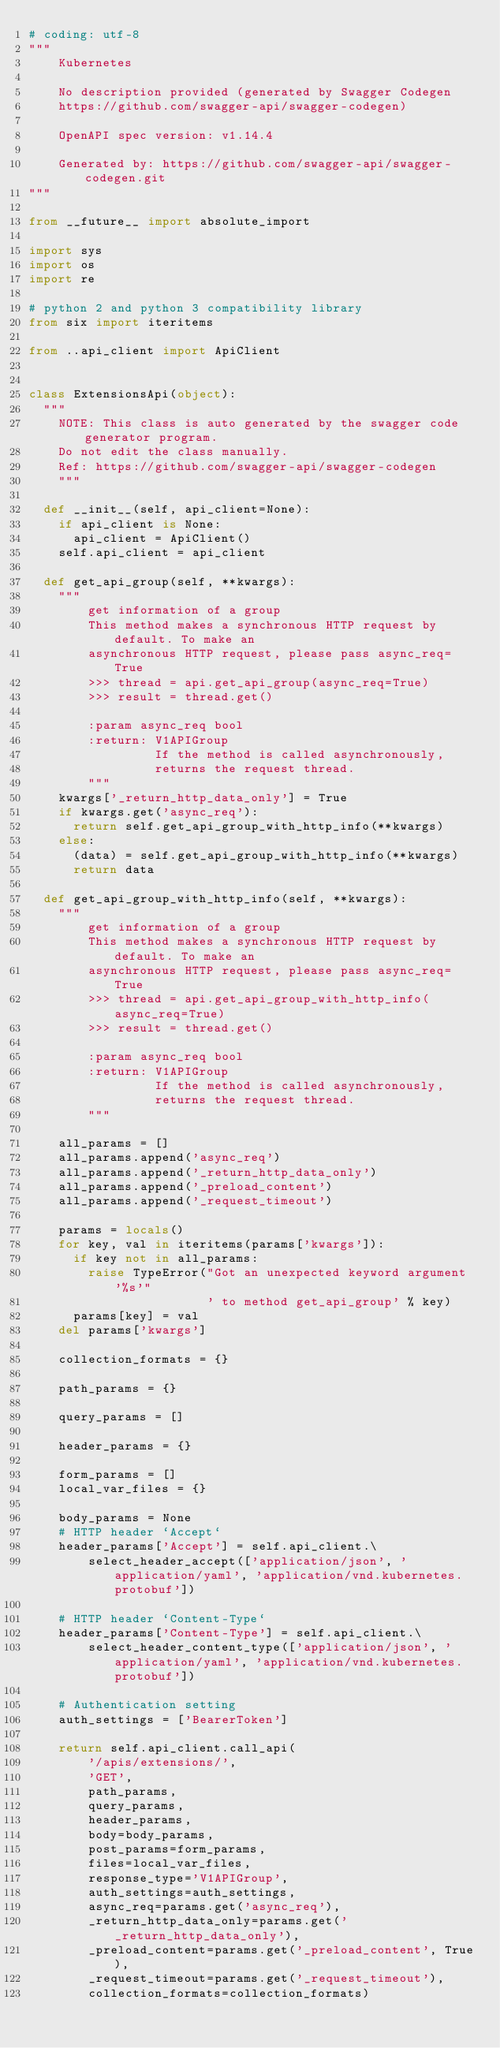Convert code to text. <code><loc_0><loc_0><loc_500><loc_500><_Python_># coding: utf-8
"""
    Kubernetes

    No description provided (generated by Swagger Codegen
    https://github.com/swagger-api/swagger-codegen)

    OpenAPI spec version: v1.14.4

    Generated by: https://github.com/swagger-api/swagger-codegen.git
"""

from __future__ import absolute_import

import sys
import os
import re

# python 2 and python 3 compatibility library
from six import iteritems

from ..api_client import ApiClient


class ExtensionsApi(object):
  """
    NOTE: This class is auto generated by the swagger code generator program.
    Do not edit the class manually.
    Ref: https://github.com/swagger-api/swagger-codegen
    """

  def __init__(self, api_client=None):
    if api_client is None:
      api_client = ApiClient()
    self.api_client = api_client

  def get_api_group(self, **kwargs):
    """
        get information of a group
        This method makes a synchronous HTTP request by default. To make an
        asynchronous HTTP request, please pass async_req=True
        >>> thread = api.get_api_group(async_req=True)
        >>> result = thread.get()

        :param async_req bool
        :return: V1APIGroup
                 If the method is called asynchronously,
                 returns the request thread.
        """
    kwargs['_return_http_data_only'] = True
    if kwargs.get('async_req'):
      return self.get_api_group_with_http_info(**kwargs)
    else:
      (data) = self.get_api_group_with_http_info(**kwargs)
      return data

  def get_api_group_with_http_info(self, **kwargs):
    """
        get information of a group
        This method makes a synchronous HTTP request by default. To make an
        asynchronous HTTP request, please pass async_req=True
        >>> thread = api.get_api_group_with_http_info(async_req=True)
        >>> result = thread.get()

        :param async_req bool
        :return: V1APIGroup
                 If the method is called asynchronously,
                 returns the request thread.
        """

    all_params = []
    all_params.append('async_req')
    all_params.append('_return_http_data_only')
    all_params.append('_preload_content')
    all_params.append('_request_timeout')

    params = locals()
    for key, val in iteritems(params['kwargs']):
      if key not in all_params:
        raise TypeError("Got an unexpected keyword argument '%s'"
                        ' to method get_api_group' % key)
      params[key] = val
    del params['kwargs']

    collection_formats = {}

    path_params = {}

    query_params = []

    header_params = {}

    form_params = []
    local_var_files = {}

    body_params = None
    # HTTP header `Accept`
    header_params['Accept'] = self.api_client.\
        select_header_accept(['application/json', 'application/yaml', 'application/vnd.kubernetes.protobuf'])

    # HTTP header `Content-Type`
    header_params['Content-Type'] = self.api_client.\
        select_header_content_type(['application/json', 'application/yaml', 'application/vnd.kubernetes.protobuf'])

    # Authentication setting
    auth_settings = ['BearerToken']

    return self.api_client.call_api(
        '/apis/extensions/',
        'GET',
        path_params,
        query_params,
        header_params,
        body=body_params,
        post_params=form_params,
        files=local_var_files,
        response_type='V1APIGroup',
        auth_settings=auth_settings,
        async_req=params.get('async_req'),
        _return_http_data_only=params.get('_return_http_data_only'),
        _preload_content=params.get('_preload_content', True),
        _request_timeout=params.get('_request_timeout'),
        collection_formats=collection_formats)
</code> 